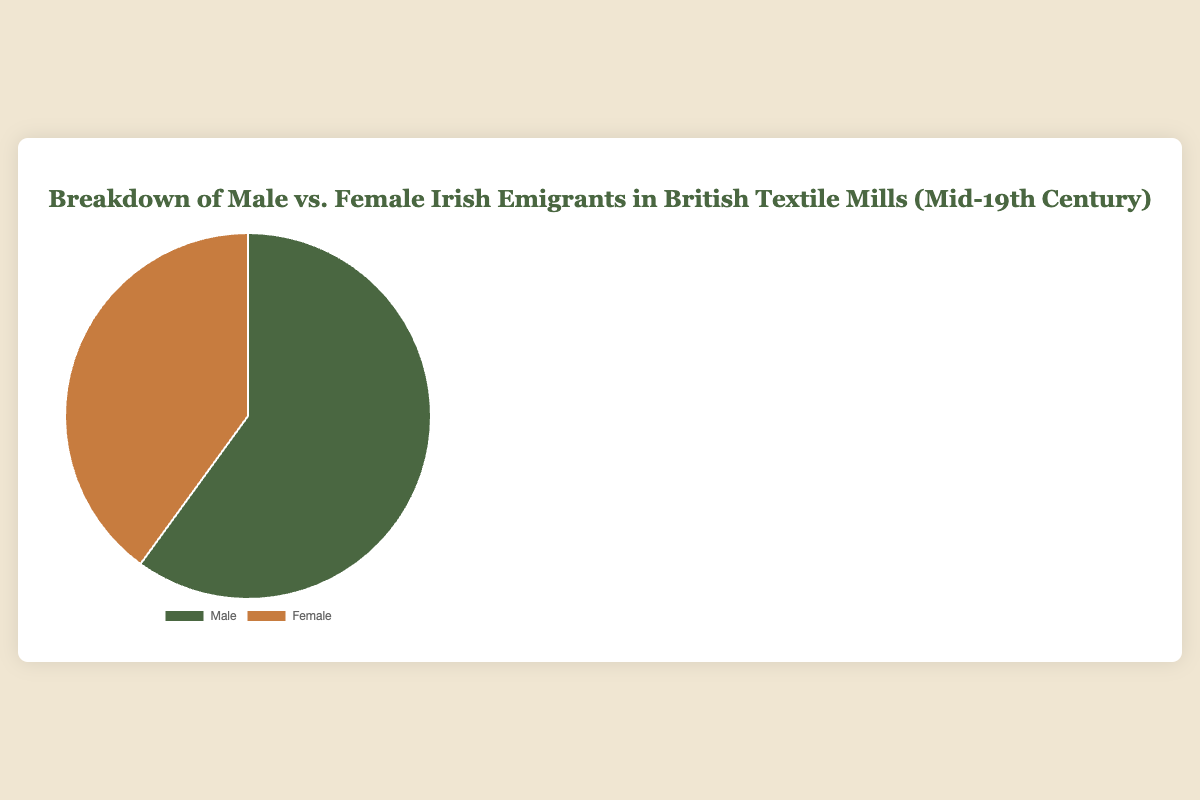What percentage of Irish emigrants working in British textile mills were male? The chart shows the data distribution between males and females. The percentage of male Irish emigrants is 60%.
Answer: 60% What percentage of Irish emigrants were female? According to the chart, the percentage of female Irish emigrants is 40%.
Answer: 40% Were there more male or female Irish emigrants working in British textile mills? The chart indicates that 60% were male and 40% were female, thus there were more males.
Answer: Male By what percentage do male Irish emigrants exceed female Irish emigrants? The difference is calculated by subtracting the percentage of females from that of males: 60% - 40% = 20%.
Answer: 20% What fraction of the Irish emigrants were male? Convert the 60% of male Irish emigrants to a fraction: \( \frac{60}{100} = \frac{3}{5} \).
Answer: 3/5 If you grouped the emigrants into a male and female category, what would be the sum of the percentages for both? The sum of the percentages for male and female Irish emigrants is 60% + 40% = 100%.
Answer: 100% Considering the given data breakdown, would you say the representation is balanced? A balanced representation would mean an equal percentage of males and females, but here males are 60% and females are 40%, indicating it is not balanced.
Answer: No What color is used to represent female Irish emigrants in the visual? Females are represented by the color that is different from males, which is described as a color close to orange-brown (#c77c3f).
Answer: Orange-Brown What is the difference in the number of male and female Irish emigrants if the total number of emigrants is 1,000? First, calculate the number of males and females: 60% of 1,000 is 600 males, and 40% is 400 females. The difference is 600 - 400 = 200.
Answer: 200 How would you describe the overall visual representation of the percentage breakdown in terms of the pie chart segments? The chart visually displays the male portion as a larger segment (60%) compared to the female segment (40%), showing that males were a significantly larger group among Irish emigrants in textile mills.
Answer: Larger male segment 